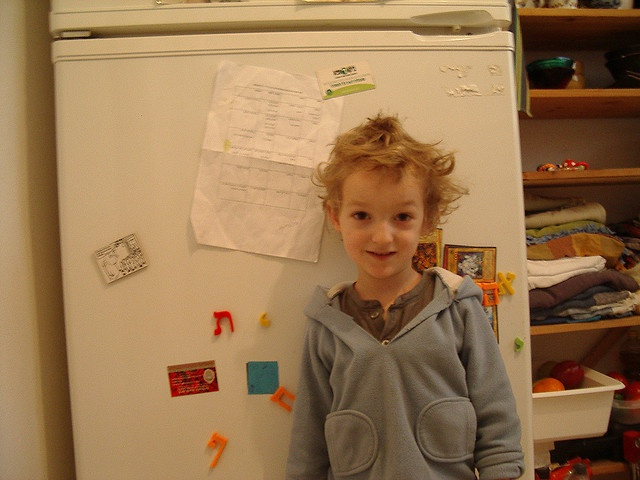Describe the objects in this image and their specific colors. I can see refrigerator in olive and tan tones, people in olive, maroon, gray, and brown tones, bowl in black, maroon, and olive tones, apple in maroon and olive tones, and bowl in olive, black, maroon, and brown tones in this image. 